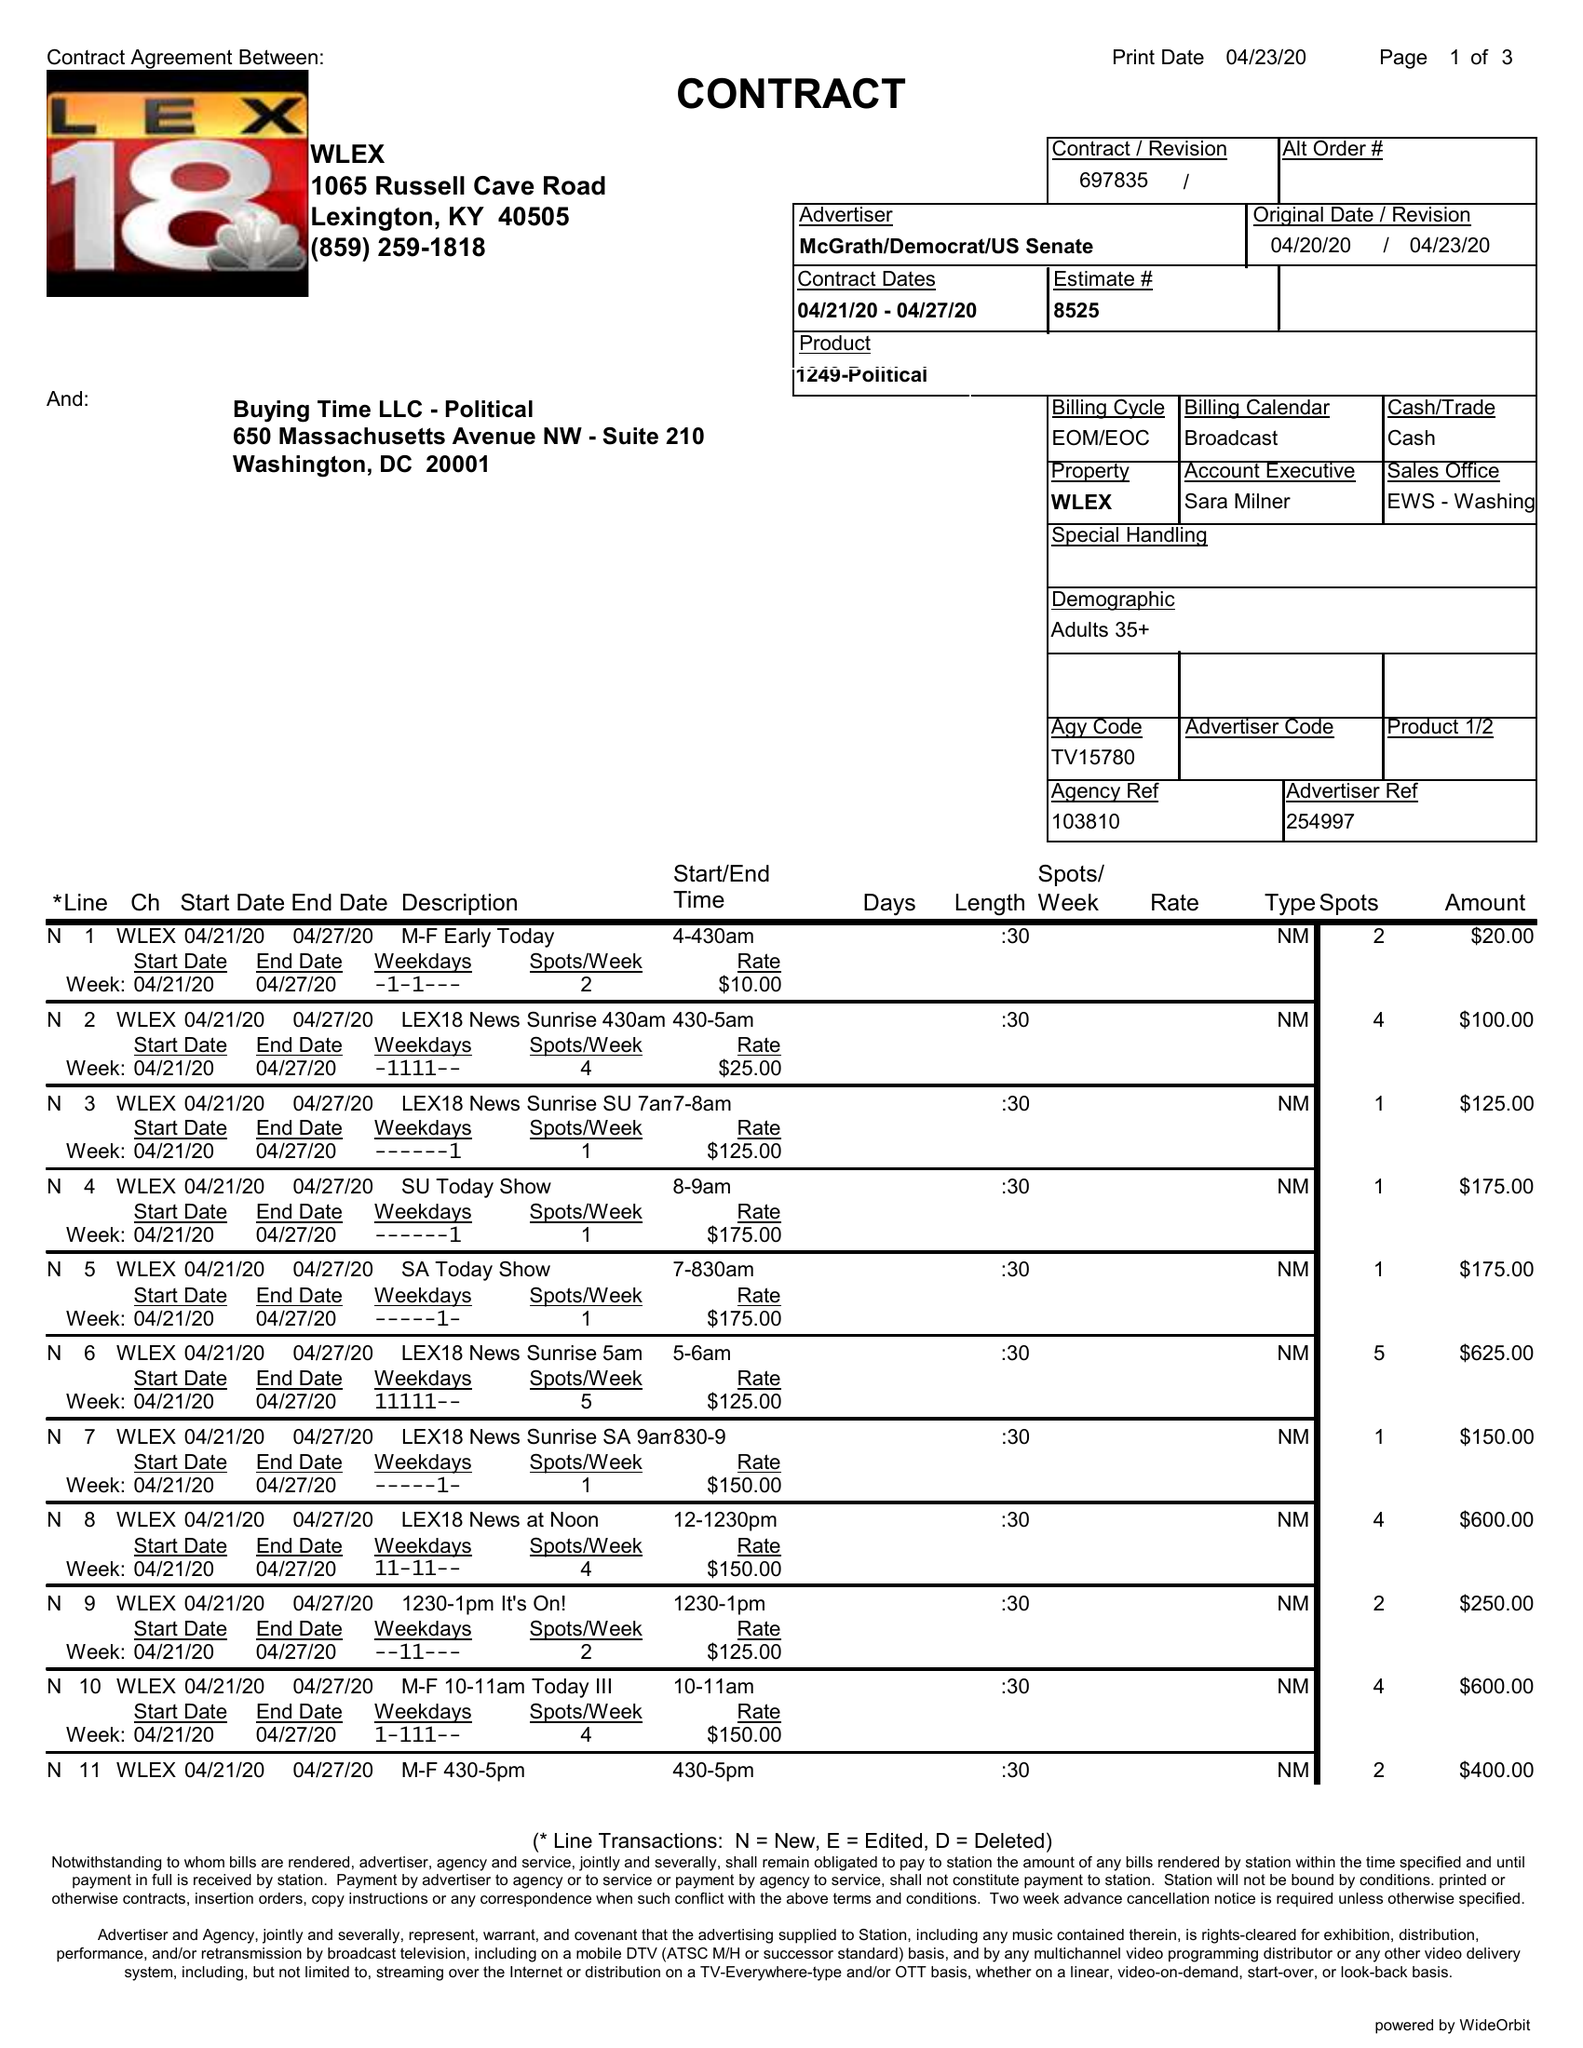What is the value for the contract_num?
Answer the question using a single word or phrase. 697835 